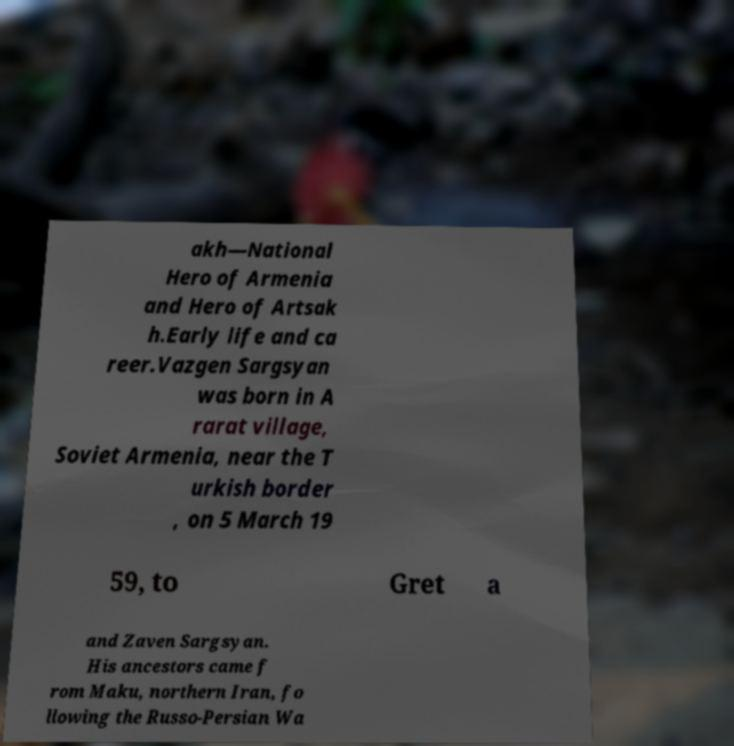I need the written content from this picture converted into text. Can you do that? akh—National Hero of Armenia and Hero of Artsak h.Early life and ca reer.Vazgen Sargsyan was born in A rarat village, Soviet Armenia, near the T urkish border , on 5 March 19 59, to Gret a and Zaven Sargsyan. His ancestors came f rom Maku, northern Iran, fo llowing the Russo-Persian Wa 